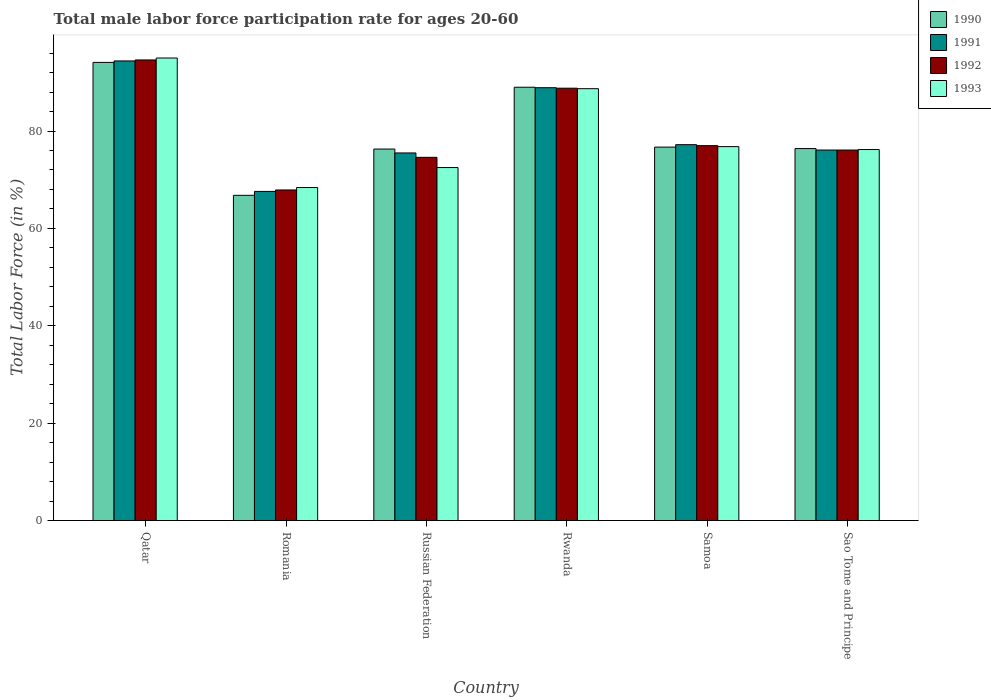How many groups of bars are there?
Your answer should be compact. 6. Are the number of bars on each tick of the X-axis equal?
Your answer should be compact. Yes. How many bars are there on the 1st tick from the left?
Make the answer very short. 4. How many bars are there on the 2nd tick from the right?
Provide a succinct answer. 4. What is the label of the 2nd group of bars from the left?
Your answer should be very brief. Romania. Across all countries, what is the maximum male labor force participation rate in 1991?
Your answer should be compact. 94.4. Across all countries, what is the minimum male labor force participation rate in 1990?
Make the answer very short. 66.8. In which country was the male labor force participation rate in 1991 maximum?
Your response must be concise. Qatar. In which country was the male labor force participation rate in 1992 minimum?
Your answer should be compact. Romania. What is the total male labor force participation rate in 1990 in the graph?
Make the answer very short. 479.3. What is the average male labor force participation rate in 1992 per country?
Provide a short and direct response. 79.83. What is the ratio of the male labor force participation rate in 1991 in Romania to that in Samoa?
Offer a terse response. 0.88. What is the difference between the highest and the second highest male labor force participation rate in 1992?
Ensure brevity in your answer.  11.8. What is the difference between the highest and the lowest male labor force participation rate in 1992?
Provide a short and direct response. 26.7. What does the 2nd bar from the left in Russian Federation represents?
Offer a terse response. 1991. Is it the case that in every country, the sum of the male labor force participation rate in 1991 and male labor force participation rate in 1993 is greater than the male labor force participation rate in 1990?
Offer a terse response. Yes. How many bars are there?
Your answer should be very brief. 24. How many countries are there in the graph?
Offer a very short reply. 6. What is the difference between two consecutive major ticks on the Y-axis?
Your response must be concise. 20. Are the values on the major ticks of Y-axis written in scientific E-notation?
Offer a terse response. No. Does the graph contain any zero values?
Provide a succinct answer. No. Does the graph contain grids?
Your response must be concise. No. How many legend labels are there?
Make the answer very short. 4. How are the legend labels stacked?
Provide a short and direct response. Vertical. What is the title of the graph?
Keep it short and to the point. Total male labor force participation rate for ages 20-60. What is the label or title of the X-axis?
Offer a very short reply. Country. What is the Total Labor Force (in %) in 1990 in Qatar?
Your answer should be very brief. 94.1. What is the Total Labor Force (in %) of 1991 in Qatar?
Your response must be concise. 94.4. What is the Total Labor Force (in %) in 1992 in Qatar?
Give a very brief answer. 94.6. What is the Total Labor Force (in %) of 1990 in Romania?
Ensure brevity in your answer.  66.8. What is the Total Labor Force (in %) in 1991 in Romania?
Your response must be concise. 67.6. What is the Total Labor Force (in %) in 1992 in Romania?
Your answer should be very brief. 67.9. What is the Total Labor Force (in %) in 1993 in Romania?
Provide a succinct answer. 68.4. What is the Total Labor Force (in %) of 1990 in Russian Federation?
Make the answer very short. 76.3. What is the Total Labor Force (in %) of 1991 in Russian Federation?
Your answer should be very brief. 75.5. What is the Total Labor Force (in %) in 1992 in Russian Federation?
Provide a succinct answer. 74.6. What is the Total Labor Force (in %) in 1993 in Russian Federation?
Your response must be concise. 72.5. What is the Total Labor Force (in %) of 1990 in Rwanda?
Keep it short and to the point. 89. What is the Total Labor Force (in %) in 1991 in Rwanda?
Your answer should be very brief. 88.9. What is the Total Labor Force (in %) of 1992 in Rwanda?
Give a very brief answer. 88.8. What is the Total Labor Force (in %) of 1993 in Rwanda?
Offer a terse response. 88.7. What is the Total Labor Force (in %) in 1990 in Samoa?
Your answer should be very brief. 76.7. What is the Total Labor Force (in %) in 1991 in Samoa?
Your response must be concise. 77.2. What is the Total Labor Force (in %) of 1992 in Samoa?
Offer a terse response. 77. What is the Total Labor Force (in %) of 1993 in Samoa?
Give a very brief answer. 76.8. What is the Total Labor Force (in %) in 1990 in Sao Tome and Principe?
Your answer should be very brief. 76.4. What is the Total Labor Force (in %) of 1991 in Sao Tome and Principe?
Your answer should be very brief. 76.1. What is the Total Labor Force (in %) in 1992 in Sao Tome and Principe?
Give a very brief answer. 76.1. What is the Total Labor Force (in %) of 1993 in Sao Tome and Principe?
Provide a short and direct response. 76.2. Across all countries, what is the maximum Total Labor Force (in %) in 1990?
Give a very brief answer. 94.1. Across all countries, what is the maximum Total Labor Force (in %) of 1991?
Offer a very short reply. 94.4. Across all countries, what is the maximum Total Labor Force (in %) in 1992?
Your answer should be compact. 94.6. Across all countries, what is the minimum Total Labor Force (in %) in 1990?
Your response must be concise. 66.8. Across all countries, what is the minimum Total Labor Force (in %) of 1991?
Provide a succinct answer. 67.6. Across all countries, what is the minimum Total Labor Force (in %) of 1992?
Offer a very short reply. 67.9. Across all countries, what is the minimum Total Labor Force (in %) in 1993?
Offer a very short reply. 68.4. What is the total Total Labor Force (in %) of 1990 in the graph?
Your answer should be compact. 479.3. What is the total Total Labor Force (in %) in 1991 in the graph?
Keep it short and to the point. 479.7. What is the total Total Labor Force (in %) in 1992 in the graph?
Provide a succinct answer. 479. What is the total Total Labor Force (in %) of 1993 in the graph?
Ensure brevity in your answer.  477.6. What is the difference between the Total Labor Force (in %) in 1990 in Qatar and that in Romania?
Provide a short and direct response. 27.3. What is the difference between the Total Labor Force (in %) in 1991 in Qatar and that in Romania?
Your answer should be compact. 26.8. What is the difference between the Total Labor Force (in %) of 1992 in Qatar and that in Romania?
Provide a short and direct response. 26.7. What is the difference between the Total Labor Force (in %) in 1993 in Qatar and that in Romania?
Keep it short and to the point. 26.6. What is the difference between the Total Labor Force (in %) of 1991 in Qatar and that in Rwanda?
Offer a terse response. 5.5. What is the difference between the Total Labor Force (in %) of 1991 in Qatar and that in Samoa?
Ensure brevity in your answer.  17.2. What is the difference between the Total Labor Force (in %) in 1993 in Qatar and that in Samoa?
Keep it short and to the point. 18.2. What is the difference between the Total Labor Force (in %) of 1991 in Qatar and that in Sao Tome and Principe?
Ensure brevity in your answer.  18.3. What is the difference between the Total Labor Force (in %) of 1990 in Romania and that in Russian Federation?
Offer a terse response. -9.5. What is the difference between the Total Labor Force (in %) of 1991 in Romania and that in Russian Federation?
Ensure brevity in your answer.  -7.9. What is the difference between the Total Labor Force (in %) of 1992 in Romania and that in Russian Federation?
Ensure brevity in your answer.  -6.7. What is the difference between the Total Labor Force (in %) in 1990 in Romania and that in Rwanda?
Offer a very short reply. -22.2. What is the difference between the Total Labor Force (in %) of 1991 in Romania and that in Rwanda?
Keep it short and to the point. -21.3. What is the difference between the Total Labor Force (in %) of 1992 in Romania and that in Rwanda?
Offer a very short reply. -20.9. What is the difference between the Total Labor Force (in %) of 1993 in Romania and that in Rwanda?
Your response must be concise. -20.3. What is the difference between the Total Labor Force (in %) in 1991 in Romania and that in Samoa?
Your answer should be compact. -9.6. What is the difference between the Total Labor Force (in %) of 1992 in Romania and that in Sao Tome and Principe?
Provide a short and direct response. -8.2. What is the difference between the Total Labor Force (in %) of 1993 in Romania and that in Sao Tome and Principe?
Offer a very short reply. -7.8. What is the difference between the Total Labor Force (in %) in 1991 in Russian Federation and that in Rwanda?
Give a very brief answer. -13.4. What is the difference between the Total Labor Force (in %) in 1992 in Russian Federation and that in Rwanda?
Your response must be concise. -14.2. What is the difference between the Total Labor Force (in %) of 1993 in Russian Federation and that in Rwanda?
Provide a succinct answer. -16.2. What is the difference between the Total Labor Force (in %) of 1992 in Russian Federation and that in Samoa?
Make the answer very short. -2.4. What is the difference between the Total Labor Force (in %) of 1990 in Russian Federation and that in Sao Tome and Principe?
Provide a short and direct response. -0.1. What is the difference between the Total Labor Force (in %) in 1992 in Russian Federation and that in Sao Tome and Principe?
Your answer should be compact. -1.5. What is the difference between the Total Labor Force (in %) of 1993 in Russian Federation and that in Sao Tome and Principe?
Offer a terse response. -3.7. What is the difference between the Total Labor Force (in %) of 1990 in Rwanda and that in Samoa?
Ensure brevity in your answer.  12.3. What is the difference between the Total Labor Force (in %) in 1990 in Rwanda and that in Sao Tome and Principe?
Give a very brief answer. 12.6. What is the difference between the Total Labor Force (in %) in 1991 in Rwanda and that in Sao Tome and Principe?
Offer a terse response. 12.8. What is the difference between the Total Labor Force (in %) of 1990 in Samoa and that in Sao Tome and Principe?
Keep it short and to the point. 0.3. What is the difference between the Total Labor Force (in %) in 1991 in Samoa and that in Sao Tome and Principe?
Your answer should be very brief. 1.1. What is the difference between the Total Labor Force (in %) of 1992 in Samoa and that in Sao Tome and Principe?
Make the answer very short. 0.9. What is the difference between the Total Labor Force (in %) in 1990 in Qatar and the Total Labor Force (in %) in 1991 in Romania?
Ensure brevity in your answer.  26.5. What is the difference between the Total Labor Force (in %) of 1990 in Qatar and the Total Labor Force (in %) of 1992 in Romania?
Your answer should be very brief. 26.2. What is the difference between the Total Labor Force (in %) of 1990 in Qatar and the Total Labor Force (in %) of 1993 in Romania?
Give a very brief answer. 25.7. What is the difference between the Total Labor Force (in %) of 1991 in Qatar and the Total Labor Force (in %) of 1992 in Romania?
Keep it short and to the point. 26.5. What is the difference between the Total Labor Force (in %) of 1991 in Qatar and the Total Labor Force (in %) of 1993 in Romania?
Ensure brevity in your answer.  26. What is the difference between the Total Labor Force (in %) of 1992 in Qatar and the Total Labor Force (in %) of 1993 in Romania?
Make the answer very short. 26.2. What is the difference between the Total Labor Force (in %) in 1990 in Qatar and the Total Labor Force (in %) in 1991 in Russian Federation?
Keep it short and to the point. 18.6. What is the difference between the Total Labor Force (in %) of 1990 in Qatar and the Total Labor Force (in %) of 1993 in Russian Federation?
Offer a terse response. 21.6. What is the difference between the Total Labor Force (in %) in 1991 in Qatar and the Total Labor Force (in %) in 1992 in Russian Federation?
Give a very brief answer. 19.8. What is the difference between the Total Labor Force (in %) in 1991 in Qatar and the Total Labor Force (in %) in 1993 in Russian Federation?
Your response must be concise. 21.9. What is the difference between the Total Labor Force (in %) of 1992 in Qatar and the Total Labor Force (in %) of 1993 in Russian Federation?
Offer a very short reply. 22.1. What is the difference between the Total Labor Force (in %) in 1991 in Qatar and the Total Labor Force (in %) in 1992 in Rwanda?
Provide a short and direct response. 5.6. What is the difference between the Total Labor Force (in %) in 1990 in Qatar and the Total Labor Force (in %) in 1991 in Samoa?
Make the answer very short. 16.9. What is the difference between the Total Labor Force (in %) of 1990 in Qatar and the Total Labor Force (in %) of 1993 in Samoa?
Keep it short and to the point. 17.3. What is the difference between the Total Labor Force (in %) in 1991 in Qatar and the Total Labor Force (in %) in 1992 in Samoa?
Make the answer very short. 17.4. What is the difference between the Total Labor Force (in %) in 1991 in Qatar and the Total Labor Force (in %) in 1993 in Samoa?
Offer a terse response. 17.6. What is the difference between the Total Labor Force (in %) in 1992 in Qatar and the Total Labor Force (in %) in 1993 in Samoa?
Provide a short and direct response. 17.8. What is the difference between the Total Labor Force (in %) in 1990 in Qatar and the Total Labor Force (in %) in 1991 in Sao Tome and Principe?
Provide a succinct answer. 18. What is the difference between the Total Labor Force (in %) in 1990 in Qatar and the Total Labor Force (in %) in 1993 in Sao Tome and Principe?
Your answer should be compact. 17.9. What is the difference between the Total Labor Force (in %) in 1992 in Qatar and the Total Labor Force (in %) in 1993 in Sao Tome and Principe?
Make the answer very short. 18.4. What is the difference between the Total Labor Force (in %) in 1990 in Romania and the Total Labor Force (in %) in 1991 in Rwanda?
Offer a terse response. -22.1. What is the difference between the Total Labor Force (in %) in 1990 in Romania and the Total Labor Force (in %) in 1992 in Rwanda?
Offer a terse response. -22. What is the difference between the Total Labor Force (in %) in 1990 in Romania and the Total Labor Force (in %) in 1993 in Rwanda?
Provide a short and direct response. -21.9. What is the difference between the Total Labor Force (in %) in 1991 in Romania and the Total Labor Force (in %) in 1992 in Rwanda?
Provide a succinct answer. -21.2. What is the difference between the Total Labor Force (in %) of 1991 in Romania and the Total Labor Force (in %) of 1993 in Rwanda?
Provide a short and direct response. -21.1. What is the difference between the Total Labor Force (in %) of 1992 in Romania and the Total Labor Force (in %) of 1993 in Rwanda?
Offer a very short reply. -20.8. What is the difference between the Total Labor Force (in %) of 1990 in Romania and the Total Labor Force (in %) of 1991 in Samoa?
Your response must be concise. -10.4. What is the difference between the Total Labor Force (in %) in 1990 in Romania and the Total Labor Force (in %) in 1993 in Samoa?
Give a very brief answer. -10. What is the difference between the Total Labor Force (in %) in 1990 in Romania and the Total Labor Force (in %) in 1992 in Sao Tome and Principe?
Make the answer very short. -9.3. What is the difference between the Total Labor Force (in %) in 1991 in Romania and the Total Labor Force (in %) in 1992 in Sao Tome and Principe?
Offer a very short reply. -8.5. What is the difference between the Total Labor Force (in %) of 1992 in Romania and the Total Labor Force (in %) of 1993 in Sao Tome and Principe?
Ensure brevity in your answer.  -8.3. What is the difference between the Total Labor Force (in %) of 1990 in Russian Federation and the Total Labor Force (in %) of 1991 in Rwanda?
Ensure brevity in your answer.  -12.6. What is the difference between the Total Labor Force (in %) of 1990 in Russian Federation and the Total Labor Force (in %) of 1992 in Rwanda?
Give a very brief answer. -12.5. What is the difference between the Total Labor Force (in %) of 1990 in Russian Federation and the Total Labor Force (in %) of 1993 in Rwanda?
Give a very brief answer. -12.4. What is the difference between the Total Labor Force (in %) of 1992 in Russian Federation and the Total Labor Force (in %) of 1993 in Rwanda?
Make the answer very short. -14.1. What is the difference between the Total Labor Force (in %) of 1990 in Russian Federation and the Total Labor Force (in %) of 1991 in Samoa?
Provide a succinct answer. -0.9. What is the difference between the Total Labor Force (in %) in 1990 in Russian Federation and the Total Labor Force (in %) in 1993 in Samoa?
Your response must be concise. -0.5. What is the difference between the Total Labor Force (in %) of 1991 in Russian Federation and the Total Labor Force (in %) of 1993 in Samoa?
Offer a very short reply. -1.3. What is the difference between the Total Labor Force (in %) in 1992 in Russian Federation and the Total Labor Force (in %) in 1993 in Samoa?
Your answer should be very brief. -2.2. What is the difference between the Total Labor Force (in %) in 1990 in Russian Federation and the Total Labor Force (in %) in 1992 in Sao Tome and Principe?
Your response must be concise. 0.2. What is the difference between the Total Labor Force (in %) in 1990 in Russian Federation and the Total Labor Force (in %) in 1993 in Sao Tome and Principe?
Ensure brevity in your answer.  0.1. What is the difference between the Total Labor Force (in %) in 1991 in Russian Federation and the Total Labor Force (in %) in 1992 in Sao Tome and Principe?
Your answer should be compact. -0.6. What is the difference between the Total Labor Force (in %) of 1991 in Russian Federation and the Total Labor Force (in %) of 1993 in Sao Tome and Principe?
Provide a short and direct response. -0.7. What is the difference between the Total Labor Force (in %) in 1990 in Rwanda and the Total Labor Force (in %) in 1991 in Samoa?
Give a very brief answer. 11.8. What is the difference between the Total Labor Force (in %) of 1991 in Rwanda and the Total Labor Force (in %) of 1992 in Samoa?
Your response must be concise. 11.9. What is the difference between the Total Labor Force (in %) in 1991 in Rwanda and the Total Labor Force (in %) in 1993 in Samoa?
Your answer should be compact. 12.1. What is the difference between the Total Labor Force (in %) in 1992 in Rwanda and the Total Labor Force (in %) in 1993 in Samoa?
Offer a terse response. 12. What is the difference between the Total Labor Force (in %) of 1990 in Rwanda and the Total Labor Force (in %) of 1992 in Sao Tome and Principe?
Your response must be concise. 12.9. What is the difference between the Total Labor Force (in %) of 1991 in Rwanda and the Total Labor Force (in %) of 1992 in Sao Tome and Principe?
Your answer should be very brief. 12.8. What is the difference between the Total Labor Force (in %) in 1991 in Rwanda and the Total Labor Force (in %) in 1993 in Sao Tome and Principe?
Give a very brief answer. 12.7. What is the difference between the Total Labor Force (in %) of 1992 in Rwanda and the Total Labor Force (in %) of 1993 in Sao Tome and Principe?
Provide a short and direct response. 12.6. What is the difference between the Total Labor Force (in %) in 1990 in Samoa and the Total Labor Force (in %) in 1993 in Sao Tome and Principe?
Give a very brief answer. 0.5. What is the difference between the Total Labor Force (in %) in 1991 in Samoa and the Total Labor Force (in %) in 1992 in Sao Tome and Principe?
Your answer should be compact. 1.1. What is the difference between the Total Labor Force (in %) in 1991 in Samoa and the Total Labor Force (in %) in 1993 in Sao Tome and Principe?
Ensure brevity in your answer.  1. What is the difference between the Total Labor Force (in %) of 1992 in Samoa and the Total Labor Force (in %) of 1993 in Sao Tome and Principe?
Provide a short and direct response. 0.8. What is the average Total Labor Force (in %) in 1990 per country?
Your answer should be compact. 79.88. What is the average Total Labor Force (in %) in 1991 per country?
Your answer should be very brief. 79.95. What is the average Total Labor Force (in %) in 1992 per country?
Ensure brevity in your answer.  79.83. What is the average Total Labor Force (in %) of 1993 per country?
Your answer should be compact. 79.6. What is the difference between the Total Labor Force (in %) of 1990 and Total Labor Force (in %) of 1991 in Qatar?
Ensure brevity in your answer.  -0.3. What is the difference between the Total Labor Force (in %) of 1991 and Total Labor Force (in %) of 1992 in Qatar?
Ensure brevity in your answer.  -0.2. What is the difference between the Total Labor Force (in %) of 1992 and Total Labor Force (in %) of 1993 in Qatar?
Make the answer very short. -0.4. What is the difference between the Total Labor Force (in %) of 1990 and Total Labor Force (in %) of 1991 in Romania?
Keep it short and to the point. -0.8. What is the difference between the Total Labor Force (in %) in 1990 and Total Labor Force (in %) in 1992 in Romania?
Offer a very short reply. -1.1. What is the difference between the Total Labor Force (in %) of 1991 and Total Labor Force (in %) of 1992 in Romania?
Provide a short and direct response. -0.3. What is the difference between the Total Labor Force (in %) of 1991 and Total Labor Force (in %) of 1993 in Romania?
Offer a terse response. -0.8. What is the difference between the Total Labor Force (in %) of 1990 and Total Labor Force (in %) of 1991 in Russian Federation?
Offer a terse response. 0.8. What is the difference between the Total Labor Force (in %) in 1990 and Total Labor Force (in %) in 1992 in Russian Federation?
Ensure brevity in your answer.  1.7. What is the difference between the Total Labor Force (in %) of 1990 and Total Labor Force (in %) of 1993 in Russian Federation?
Provide a succinct answer. 3.8. What is the difference between the Total Labor Force (in %) in 1991 and Total Labor Force (in %) in 1992 in Russian Federation?
Provide a succinct answer. 0.9. What is the difference between the Total Labor Force (in %) in 1991 and Total Labor Force (in %) in 1993 in Russian Federation?
Provide a short and direct response. 3. What is the difference between the Total Labor Force (in %) of 1990 and Total Labor Force (in %) of 1992 in Rwanda?
Give a very brief answer. 0.2. What is the difference between the Total Labor Force (in %) of 1990 and Total Labor Force (in %) of 1993 in Rwanda?
Your answer should be compact. 0.3. What is the difference between the Total Labor Force (in %) in 1991 and Total Labor Force (in %) in 1992 in Rwanda?
Offer a very short reply. 0.1. What is the difference between the Total Labor Force (in %) of 1990 and Total Labor Force (in %) of 1993 in Samoa?
Offer a terse response. -0.1. What is the difference between the Total Labor Force (in %) in 1992 and Total Labor Force (in %) in 1993 in Samoa?
Provide a succinct answer. 0.2. What is the difference between the Total Labor Force (in %) in 1990 and Total Labor Force (in %) in 1991 in Sao Tome and Principe?
Provide a short and direct response. 0.3. What is the difference between the Total Labor Force (in %) in 1990 and Total Labor Force (in %) in 1993 in Sao Tome and Principe?
Provide a succinct answer. 0.2. What is the difference between the Total Labor Force (in %) in 1992 and Total Labor Force (in %) in 1993 in Sao Tome and Principe?
Offer a very short reply. -0.1. What is the ratio of the Total Labor Force (in %) in 1990 in Qatar to that in Romania?
Your answer should be very brief. 1.41. What is the ratio of the Total Labor Force (in %) in 1991 in Qatar to that in Romania?
Offer a terse response. 1.4. What is the ratio of the Total Labor Force (in %) of 1992 in Qatar to that in Romania?
Give a very brief answer. 1.39. What is the ratio of the Total Labor Force (in %) of 1993 in Qatar to that in Romania?
Make the answer very short. 1.39. What is the ratio of the Total Labor Force (in %) in 1990 in Qatar to that in Russian Federation?
Your response must be concise. 1.23. What is the ratio of the Total Labor Force (in %) in 1991 in Qatar to that in Russian Federation?
Provide a short and direct response. 1.25. What is the ratio of the Total Labor Force (in %) in 1992 in Qatar to that in Russian Federation?
Your response must be concise. 1.27. What is the ratio of the Total Labor Force (in %) in 1993 in Qatar to that in Russian Federation?
Keep it short and to the point. 1.31. What is the ratio of the Total Labor Force (in %) in 1990 in Qatar to that in Rwanda?
Offer a very short reply. 1.06. What is the ratio of the Total Labor Force (in %) in 1991 in Qatar to that in Rwanda?
Ensure brevity in your answer.  1.06. What is the ratio of the Total Labor Force (in %) of 1992 in Qatar to that in Rwanda?
Provide a succinct answer. 1.07. What is the ratio of the Total Labor Force (in %) in 1993 in Qatar to that in Rwanda?
Keep it short and to the point. 1.07. What is the ratio of the Total Labor Force (in %) in 1990 in Qatar to that in Samoa?
Offer a terse response. 1.23. What is the ratio of the Total Labor Force (in %) of 1991 in Qatar to that in Samoa?
Ensure brevity in your answer.  1.22. What is the ratio of the Total Labor Force (in %) in 1992 in Qatar to that in Samoa?
Give a very brief answer. 1.23. What is the ratio of the Total Labor Force (in %) of 1993 in Qatar to that in Samoa?
Ensure brevity in your answer.  1.24. What is the ratio of the Total Labor Force (in %) of 1990 in Qatar to that in Sao Tome and Principe?
Provide a short and direct response. 1.23. What is the ratio of the Total Labor Force (in %) of 1991 in Qatar to that in Sao Tome and Principe?
Make the answer very short. 1.24. What is the ratio of the Total Labor Force (in %) of 1992 in Qatar to that in Sao Tome and Principe?
Keep it short and to the point. 1.24. What is the ratio of the Total Labor Force (in %) of 1993 in Qatar to that in Sao Tome and Principe?
Ensure brevity in your answer.  1.25. What is the ratio of the Total Labor Force (in %) of 1990 in Romania to that in Russian Federation?
Your response must be concise. 0.88. What is the ratio of the Total Labor Force (in %) in 1991 in Romania to that in Russian Federation?
Provide a short and direct response. 0.9. What is the ratio of the Total Labor Force (in %) in 1992 in Romania to that in Russian Federation?
Give a very brief answer. 0.91. What is the ratio of the Total Labor Force (in %) in 1993 in Romania to that in Russian Federation?
Provide a succinct answer. 0.94. What is the ratio of the Total Labor Force (in %) in 1990 in Romania to that in Rwanda?
Give a very brief answer. 0.75. What is the ratio of the Total Labor Force (in %) in 1991 in Romania to that in Rwanda?
Provide a succinct answer. 0.76. What is the ratio of the Total Labor Force (in %) in 1992 in Romania to that in Rwanda?
Give a very brief answer. 0.76. What is the ratio of the Total Labor Force (in %) in 1993 in Romania to that in Rwanda?
Offer a very short reply. 0.77. What is the ratio of the Total Labor Force (in %) of 1990 in Romania to that in Samoa?
Give a very brief answer. 0.87. What is the ratio of the Total Labor Force (in %) in 1991 in Romania to that in Samoa?
Provide a succinct answer. 0.88. What is the ratio of the Total Labor Force (in %) of 1992 in Romania to that in Samoa?
Keep it short and to the point. 0.88. What is the ratio of the Total Labor Force (in %) of 1993 in Romania to that in Samoa?
Make the answer very short. 0.89. What is the ratio of the Total Labor Force (in %) in 1990 in Romania to that in Sao Tome and Principe?
Your answer should be very brief. 0.87. What is the ratio of the Total Labor Force (in %) in 1991 in Romania to that in Sao Tome and Principe?
Your answer should be compact. 0.89. What is the ratio of the Total Labor Force (in %) of 1992 in Romania to that in Sao Tome and Principe?
Provide a succinct answer. 0.89. What is the ratio of the Total Labor Force (in %) in 1993 in Romania to that in Sao Tome and Principe?
Offer a very short reply. 0.9. What is the ratio of the Total Labor Force (in %) in 1990 in Russian Federation to that in Rwanda?
Offer a terse response. 0.86. What is the ratio of the Total Labor Force (in %) in 1991 in Russian Federation to that in Rwanda?
Your response must be concise. 0.85. What is the ratio of the Total Labor Force (in %) of 1992 in Russian Federation to that in Rwanda?
Your response must be concise. 0.84. What is the ratio of the Total Labor Force (in %) in 1993 in Russian Federation to that in Rwanda?
Ensure brevity in your answer.  0.82. What is the ratio of the Total Labor Force (in %) in 1990 in Russian Federation to that in Samoa?
Ensure brevity in your answer.  0.99. What is the ratio of the Total Labor Force (in %) of 1991 in Russian Federation to that in Samoa?
Provide a short and direct response. 0.98. What is the ratio of the Total Labor Force (in %) of 1992 in Russian Federation to that in Samoa?
Keep it short and to the point. 0.97. What is the ratio of the Total Labor Force (in %) in 1993 in Russian Federation to that in Samoa?
Your answer should be compact. 0.94. What is the ratio of the Total Labor Force (in %) in 1990 in Russian Federation to that in Sao Tome and Principe?
Your answer should be compact. 1. What is the ratio of the Total Labor Force (in %) of 1991 in Russian Federation to that in Sao Tome and Principe?
Provide a short and direct response. 0.99. What is the ratio of the Total Labor Force (in %) in 1992 in Russian Federation to that in Sao Tome and Principe?
Provide a succinct answer. 0.98. What is the ratio of the Total Labor Force (in %) of 1993 in Russian Federation to that in Sao Tome and Principe?
Your response must be concise. 0.95. What is the ratio of the Total Labor Force (in %) in 1990 in Rwanda to that in Samoa?
Your answer should be very brief. 1.16. What is the ratio of the Total Labor Force (in %) of 1991 in Rwanda to that in Samoa?
Your response must be concise. 1.15. What is the ratio of the Total Labor Force (in %) in 1992 in Rwanda to that in Samoa?
Ensure brevity in your answer.  1.15. What is the ratio of the Total Labor Force (in %) in 1993 in Rwanda to that in Samoa?
Your answer should be very brief. 1.15. What is the ratio of the Total Labor Force (in %) of 1990 in Rwanda to that in Sao Tome and Principe?
Your answer should be compact. 1.16. What is the ratio of the Total Labor Force (in %) in 1991 in Rwanda to that in Sao Tome and Principe?
Provide a short and direct response. 1.17. What is the ratio of the Total Labor Force (in %) of 1992 in Rwanda to that in Sao Tome and Principe?
Make the answer very short. 1.17. What is the ratio of the Total Labor Force (in %) of 1993 in Rwanda to that in Sao Tome and Principe?
Ensure brevity in your answer.  1.16. What is the ratio of the Total Labor Force (in %) of 1991 in Samoa to that in Sao Tome and Principe?
Your answer should be very brief. 1.01. What is the ratio of the Total Labor Force (in %) of 1992 in Samoa to that in Sao Tome and Principe?
Give a very brief answer. 1.01. What is the ratio of the Total Labor Force (in %) of 1993 in Samoa to that in Sao Tome and Principe?
Your answer should be compact. 1.01. What is the difference between the highest and the second highest Total Labor Force (in %) in 1990?
Your answer should be very brief. 5.1. What is the difference between the highest and the second highest Total Labor Force (in %) of 1991?
Your answer should be compact. 5.5. What is the difference between the highest and the second highest Total Labor Force (in %) of 1992?
Your answer should be very brief. 5.8. What is the difference between the highest and the lowest Total Labor Force (in %) of 1990?
Offer a very short reply. 27.3. What is the difference between the highest and the lowest Total Labor Force (in %) of 1991?
Make the answer very short. 26.8. What is the difference between the highest and the lowest Total Labor Force (in %) in 1992?
Your answer should be very brief. 26.7. What is the difference between the highest and the lowest Total Labor Force (in %) of 1993?
Your response must be concise. 26.6. 